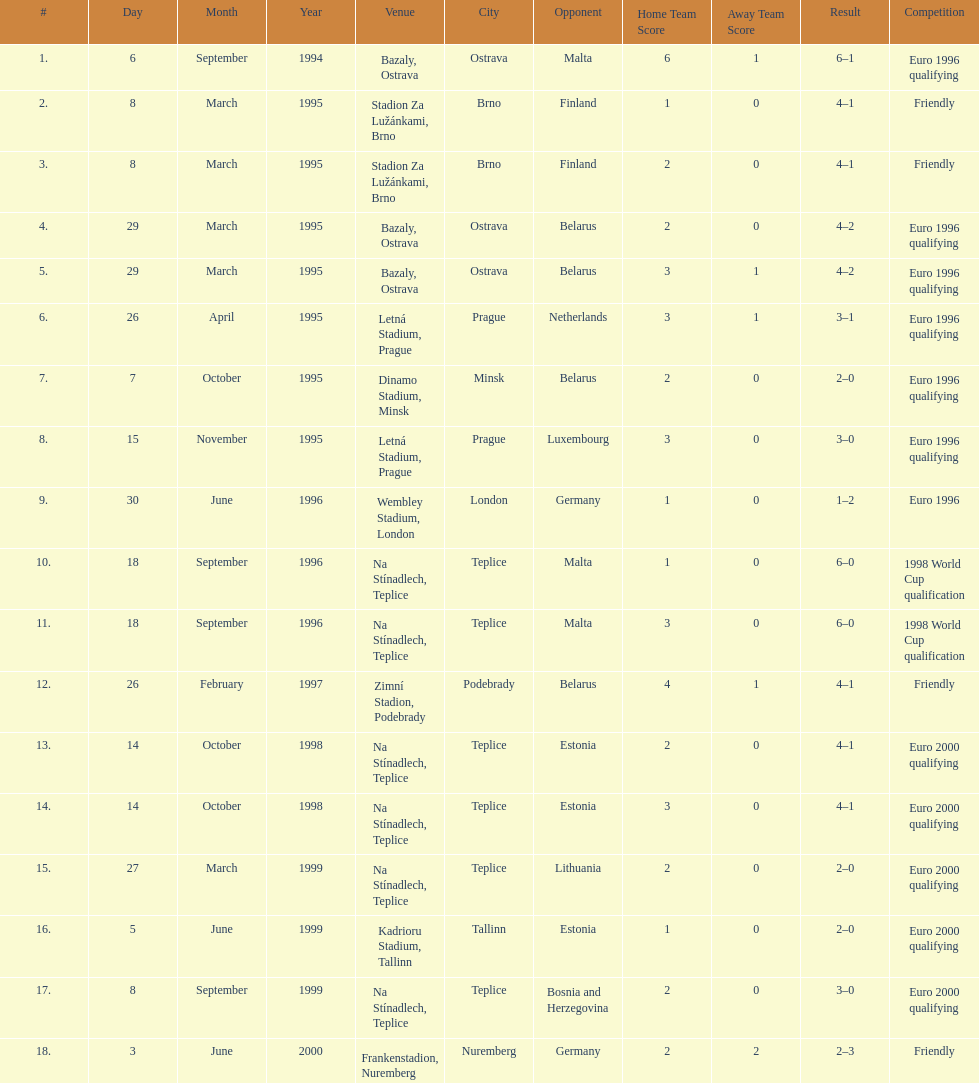Bazaly, ostrava was used on 6 september 1004, but what venue was used on 18 september 1996? Na Stínadlech, Teplice. 